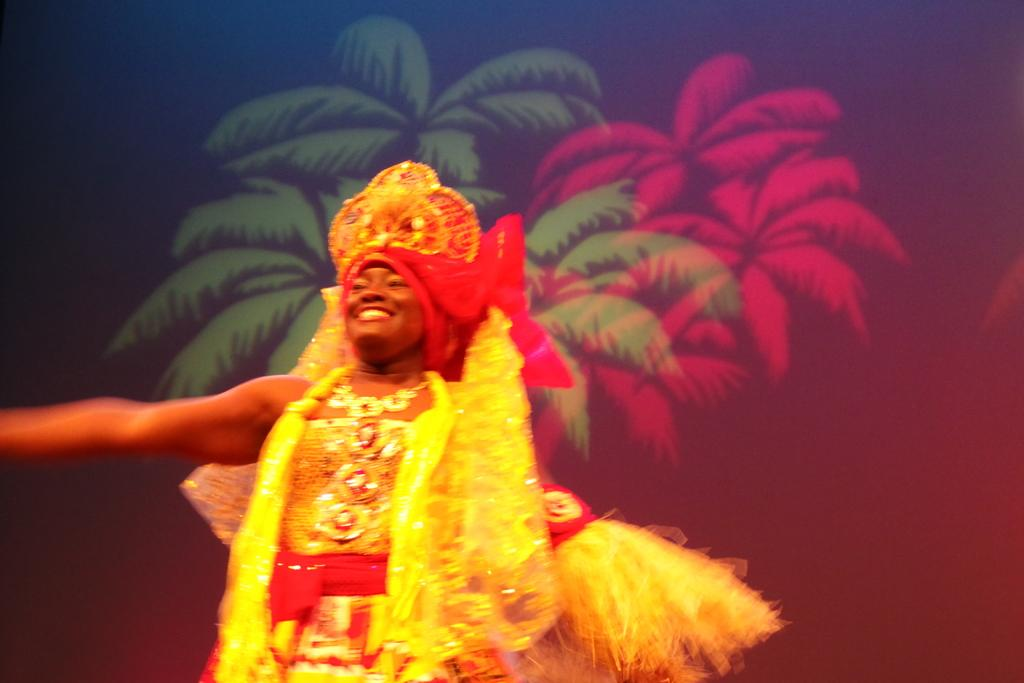What is the main subject of the image? There is a person in the image. What is the person wearing? The person is wearing a costume. What is the person doing in the image? The person is standing over a place and smiling. What can be seen in the background of the image? There is a design of trees present in the background of the image. Can you tell me how many bombs are visible in the image? There are no bombs present in the image. What type of island can be seen in the background of the image? There is no island present in the image; it features a design of trees in the background. 